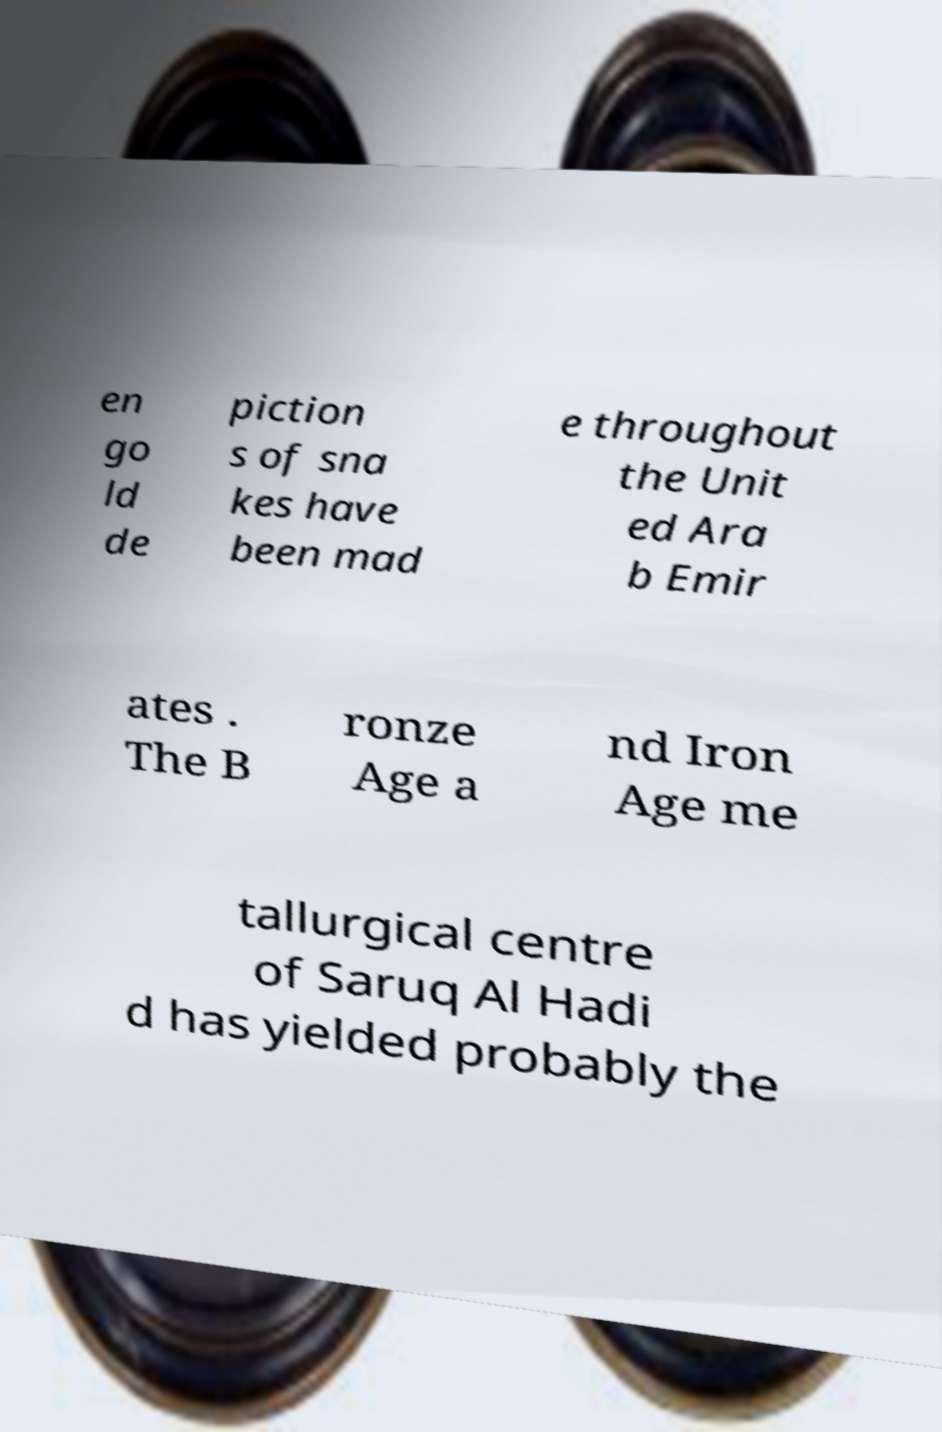Please identify and transcribe the text found in this image. en go ld de piction s of sna kes have been mad e throughout the Unit ed Ara b Emir ates . The B ronze Age a nd Iron Age me tallurgical centre of Saruq Al Hadi d has yielded probably the 